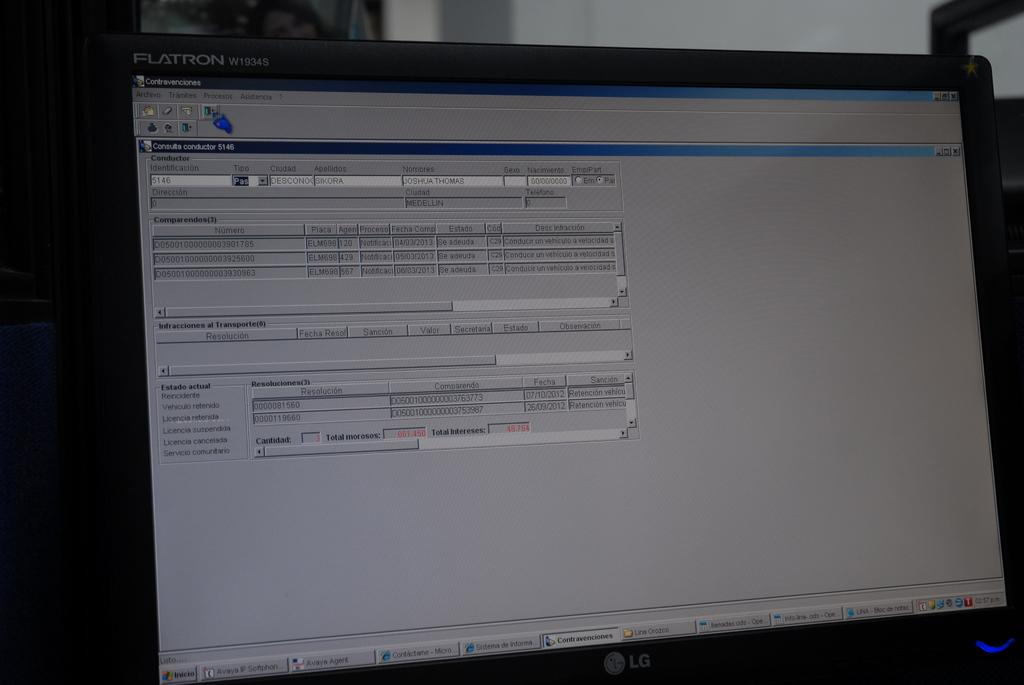Provide a one-sentence caption for the provided image. A FLATRON screen with Contravenciones on the top corner. 